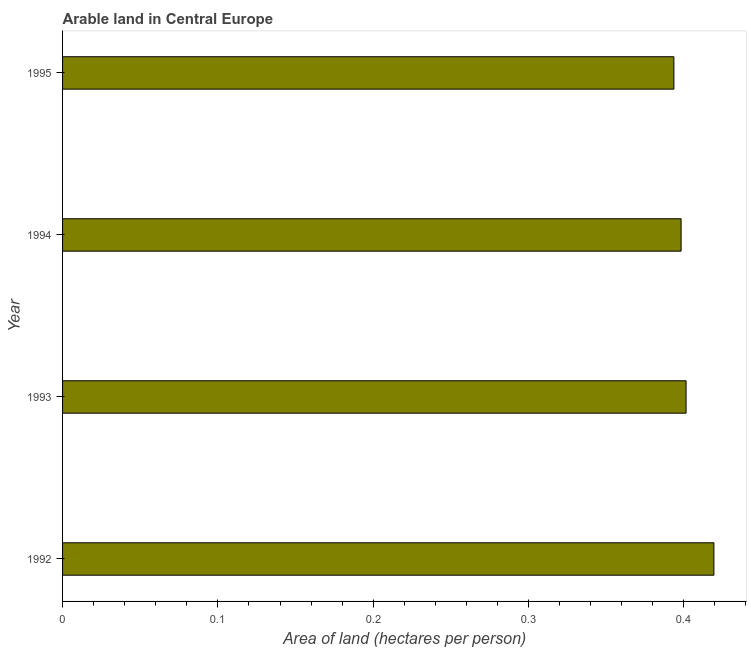Does the graph contain any zero values?
Provide a short and direct response. No. Does the graph contain grids?
Provide a succinct answer. No. What is the title of the graph?
Provide a short and direct response. Arable land in Central Europe. What is the label or title of the X-axis?
Give a very brief answer. Area of land (hectares per person). What is the label or title of the Y-axis?
Give a very brief answer. Year. What is the area of arable land in 1992?
Provide a short and direct response. 0.42. Across all years, what is the maximum area of arable land?
Give a very brief answer. 0.42. Across all years, what is the minimum area of arable land?
Offer a terse response. 0.39. In which year was the area of arable land maximum?
Your answer should be compact. 1992. What is the sum of the area of arable land?
Give a very brief answer. 1.61. What is the difference between the area of arable land in 1992 and 1993?
Ensure brevity in your answer.  0.02. What is the average area of arable land per year?
Ensure brevity in your answer.  0.4. What is the median area of arable land?
Your answer should be compact. 0.4. In how many years, is the area of arable land greater than 0.22 hectares per person?
Provide a succinct answer. 4. What is the difference between the highest and the second highest area of arable land?
Offer a terse response. 0.02. Is the sum of the area of arable land in 1994 and 1995 greater than the maximum area of arable land across all years?
Your answer should be very brief. Yes. How many bars are there?
Make the answer very short. 4. Are all the bars in the graph horizontal?
Offer a very short reply. Yes. What is the difference between two consecutive major ticks on the X-axis?
Your answer should be compact. 0.1. Are the values on the major ticks of X-axis written in scientific E-notation?
Provide a short and direct response. No. What is the Area of land (hectares per person) of 1992?
Provide a succinct answer. 0.42. What is the Area of land (hectares per person) in 1993?
Provide a succinct answer. 0.4. What is the Area of land (hectares per person) of 1994?
Ensure brevity in your answer.  0.4. What is the Area of land (hectares per person) of 1995?
Your response must be concise. 0.39. What is the difference between the Area of land (hectares per person) in 1992 and 1993?
Your answer should be compact. 0.02. What is the difference between the Area of land (hectares per person) in 1992 and 1994?
Provide a succinct answer. 0.02. What is the difference between the Area of land (hectares per person) in 1992 and 1995?
Your answer should be very brief. 0.03. What is the difference between the Area of land (hectares per person) in 1993 and 1994?
Offer a very short reply. 0. What is the difference between the Area of land (hectares per person) in 1993 and 1995?
Ensure brevity in your answer.  0.01. What is the difference between the Area of land (hectares per person) in 1994 and 1995?
Offer a terse response. 0. What is the ratio of the Area of land (hectares per person) in 1992 to that in 1993?
Your answer should be compact. 1.04. What is the ratio of the Area of land (hectares per person) in 1992 to that in 1994?
Offer a very short reply. 1.05. What is the ratio of the Area of land (hectares per person) in 1992 to that in 1995?
Offer a terse response. 1.06. 